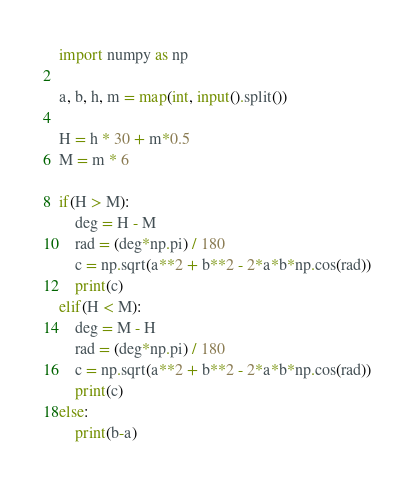<code> <loc_0><loc_0><loc_500><loc_500><_Python_>import numpy as np

a, b, h, m = map(int, input().split())

H = h * 30 + m*0.5
M = m * 6

if(H > M):
    deg = H - M
    rad = (deg*np.pi) / 180
    c = np.sqrt(a**2 + b**2 - 2*a*b*np.cos(rad))
    print(c)
elif(H < M):
    deg = M - H
    rad = (deg*np.pi) / 180
    c = np.sqrt(a**2 + b**2 - 2*a*b*np.cos(rad))
    print(c)
else:
    print(b-a)
</code> 